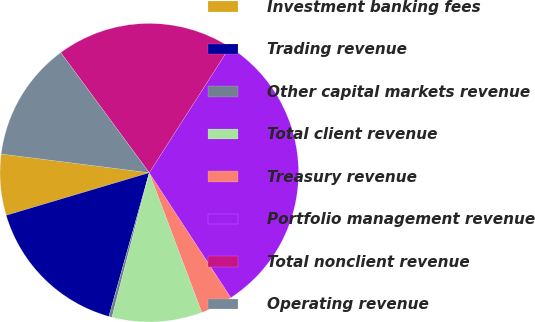<chart> <loc_0><loc_0><loc_500><loc_500><pie_chart><fcel>Investment banking fees<fcel>Trading revenue<fcel>Other capital markets revenue<fcel>Total client revenue<fcel>Treasury revenue<fcel>Portfolio management revenue<fcel>Total nonclient revenue<fcel>Operating revenue<nl><fcel>6.61%<fcel>16.03%<fcel>0.34%<fcel>9.75%<fcel>3.48%<fcel>31.72%<fcel>19.17%<fcel>12.89%<nl></chart> 